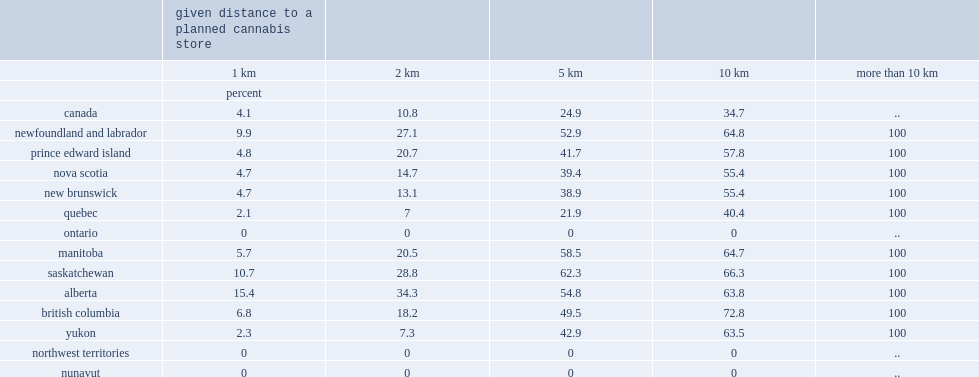What is the percentage of the population is expected to have access to cannabis outlets within 10 kilometres or less of their residence for the country as a whole? 34.7. What is the percentage of the population is expected to have access to cannabis outlets within five kilometres or less of their residence for the country as a whole? 24.9. What is the percentage of the population is expected to have access to cannabis outlets within 10 kilometres or less of their residence for british columbia? 72.8. Which place has the highest percentage of the population who is expected to have access to cannabis outlets within ten kilometres or less of their residence? British columbia. What is the percentage of the population is expected to have 10-kilometre access to cannabis stores in quebec? 40.4. What is the percentage of the population is expected to have 10-kilometre access to cannabis stores in ontario? 0.0. What is the percentage of the population is expected to have 10-kilometre access to cannabis stores in northwest territories? 0.0. What is the percentage of the population is expected to have 10-kilometre access to cannabis stores in nunavut? 0.0. Can you parse all the data within this table? {'header': ['', 'given distance to a planned cannabis store', '', '', '', ''], 'rows': [['', '1 km', '2 km', '5 km', '10 km', 'more than 10 km'], ['', 'percent', '', '', '', ''], ['canada', '4.1', '10.8', '24.9', '34.7', '..'], ['newfoundland and labrador', '9.9', '27.1', '52.9', '64.8', '100'], ['prince edward island', '4.8', '20.7', '41.7', '57.8', '100'], ['nova scotia', '4.7', '14.7', '39.4', '55.4', '100'], ['new brunswick', '4.7', '13.1', '38.9', '55.4', '100'], ['quebec', '2.1', '7', '21.9', '40.4', '100'], ['ontario', '0', '0', '0', '0', '..'], ['manitoba', '5.7', '20.5', '58.5', '64.7', '100'], ['saskatchewan', '10.7', '28.8', '62.3', '66.3', '100'], ['alberta', '15.4', '34.3', '54.8', '63.8', '100'], ['british columbia', '6.8', '18.2', '49.5', '72.8', '100'], ['yukon', '2.3', '7.3', '42.9', '63.5', '100'], ['northwest territories', '0', '0', '0', '0', '..'], ['nunavut', '0', '0', '0', '0', '..']]} 